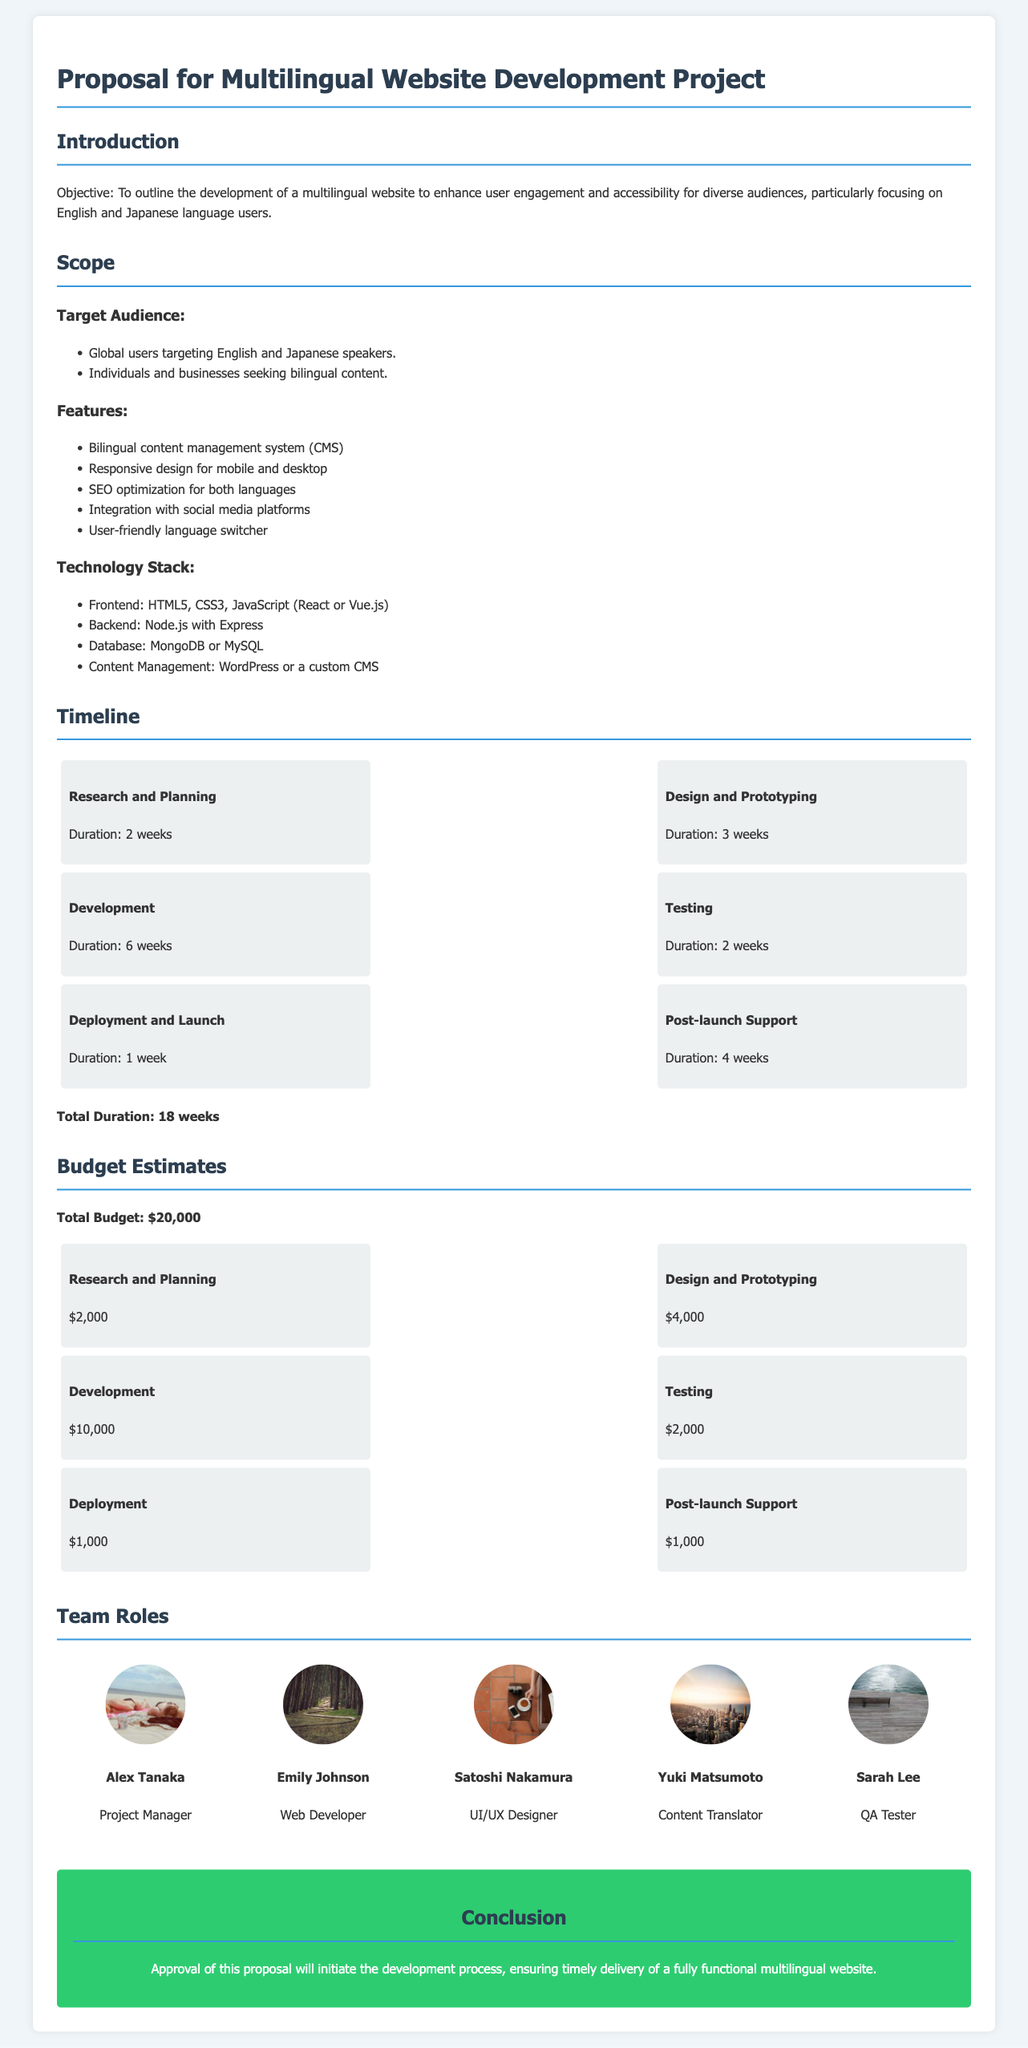what is the duration of the development phase? The document states that the development phase has a duration of 6 weeks.
Answer: 6 weeks what is the total budget for the project? The total budget for the multilingual website development project is mentioned as $20,000.
Answer: $20,000 who is the project manager? The document lists Alex Tanaka as the project manager for the team.
Answer: Alex Tanaka how many weeks is allocated for post-launch support? The post-launch support phase is allocated 4 weeks according to the timeline.
Answer: 4 weeks what technology is used for the backend? The proposal indicates that the backend technology will be Node.js with Express.
Answer: Node.js with Express which role is Yuki Matsumoto fulfilling? The document specifies that Yuki Matsumoto is the content translator on the team.
Answer: Content Translator how many phases are there in the project timeline? The timeline lists a total of 6 phases for the project development process.
Answer: 6 phases what is one of the key features of the multilingual website? The proposal highlights 'Bilingual content management system (CMS)' as a key feature.
Answer: Bilingual content management system (CMS) 